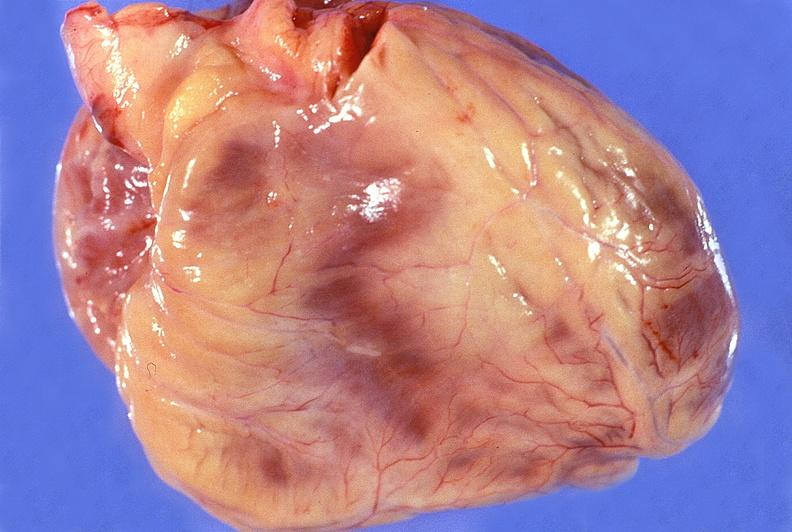does very good example show normal cardiovascular?
Answer the question using a single word or phrase. No 